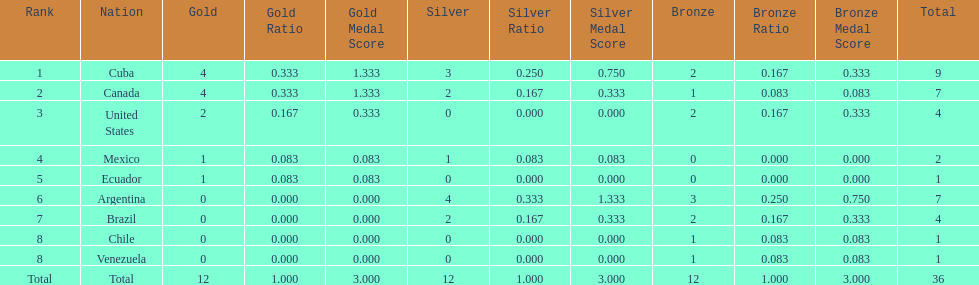Which ranking is mexico? 4. 